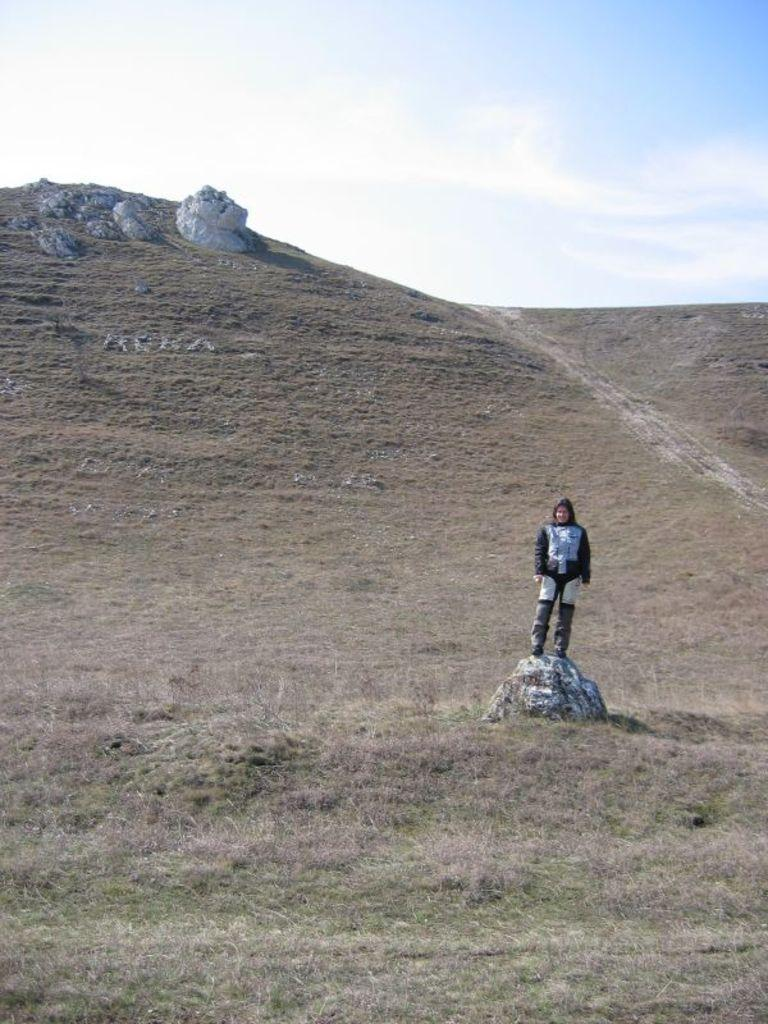What is the main subject in the image? There is a person standing in the image. What can be seen in the background of the image? The sky is visible in the image. What type of iron is being used by the person's father in the image? There is no father or iron present in the image; it only features a person standing and the sky in the background. 